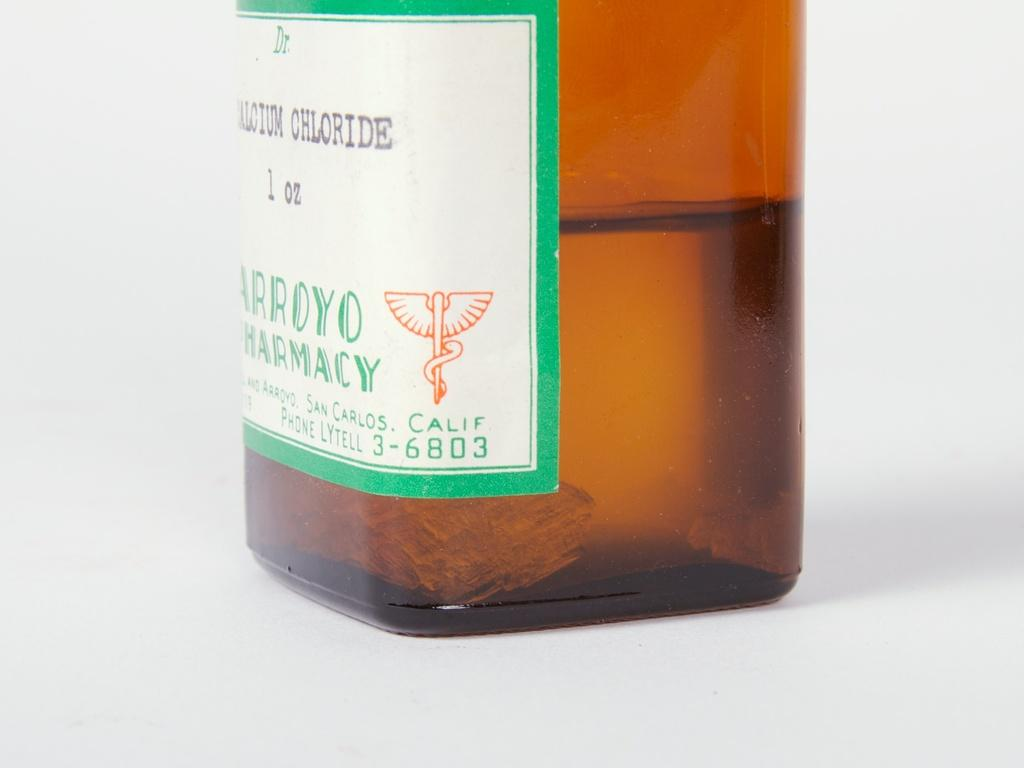Provide a one-sentence caption for the provided image. a brown bottle of medication from arroyo pharmacy in california. 